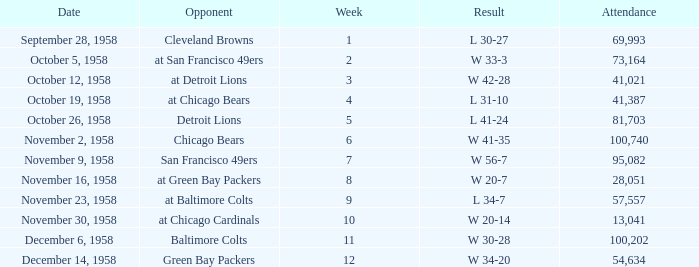What was the higest attendance on November 9, 1958? 95082.0. 